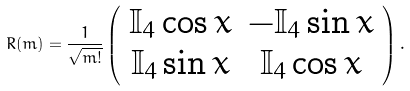<formula> <loc_0><loc_0><loc_500><loc_500>R ( m ) = \frac { 1 } { \sqrt { m ! } } \left ( \begin{array} { c c } \mathbb { I } _ { 4 } \cos { x } & - \mathbb { I } _ { 4 } \sin { x } \\ \mathbb { I } _ { 4 } \sin { x } & \mathbb { I } _ { 4 } \cos { x } \\ \end{array} \right ) .</formula> 